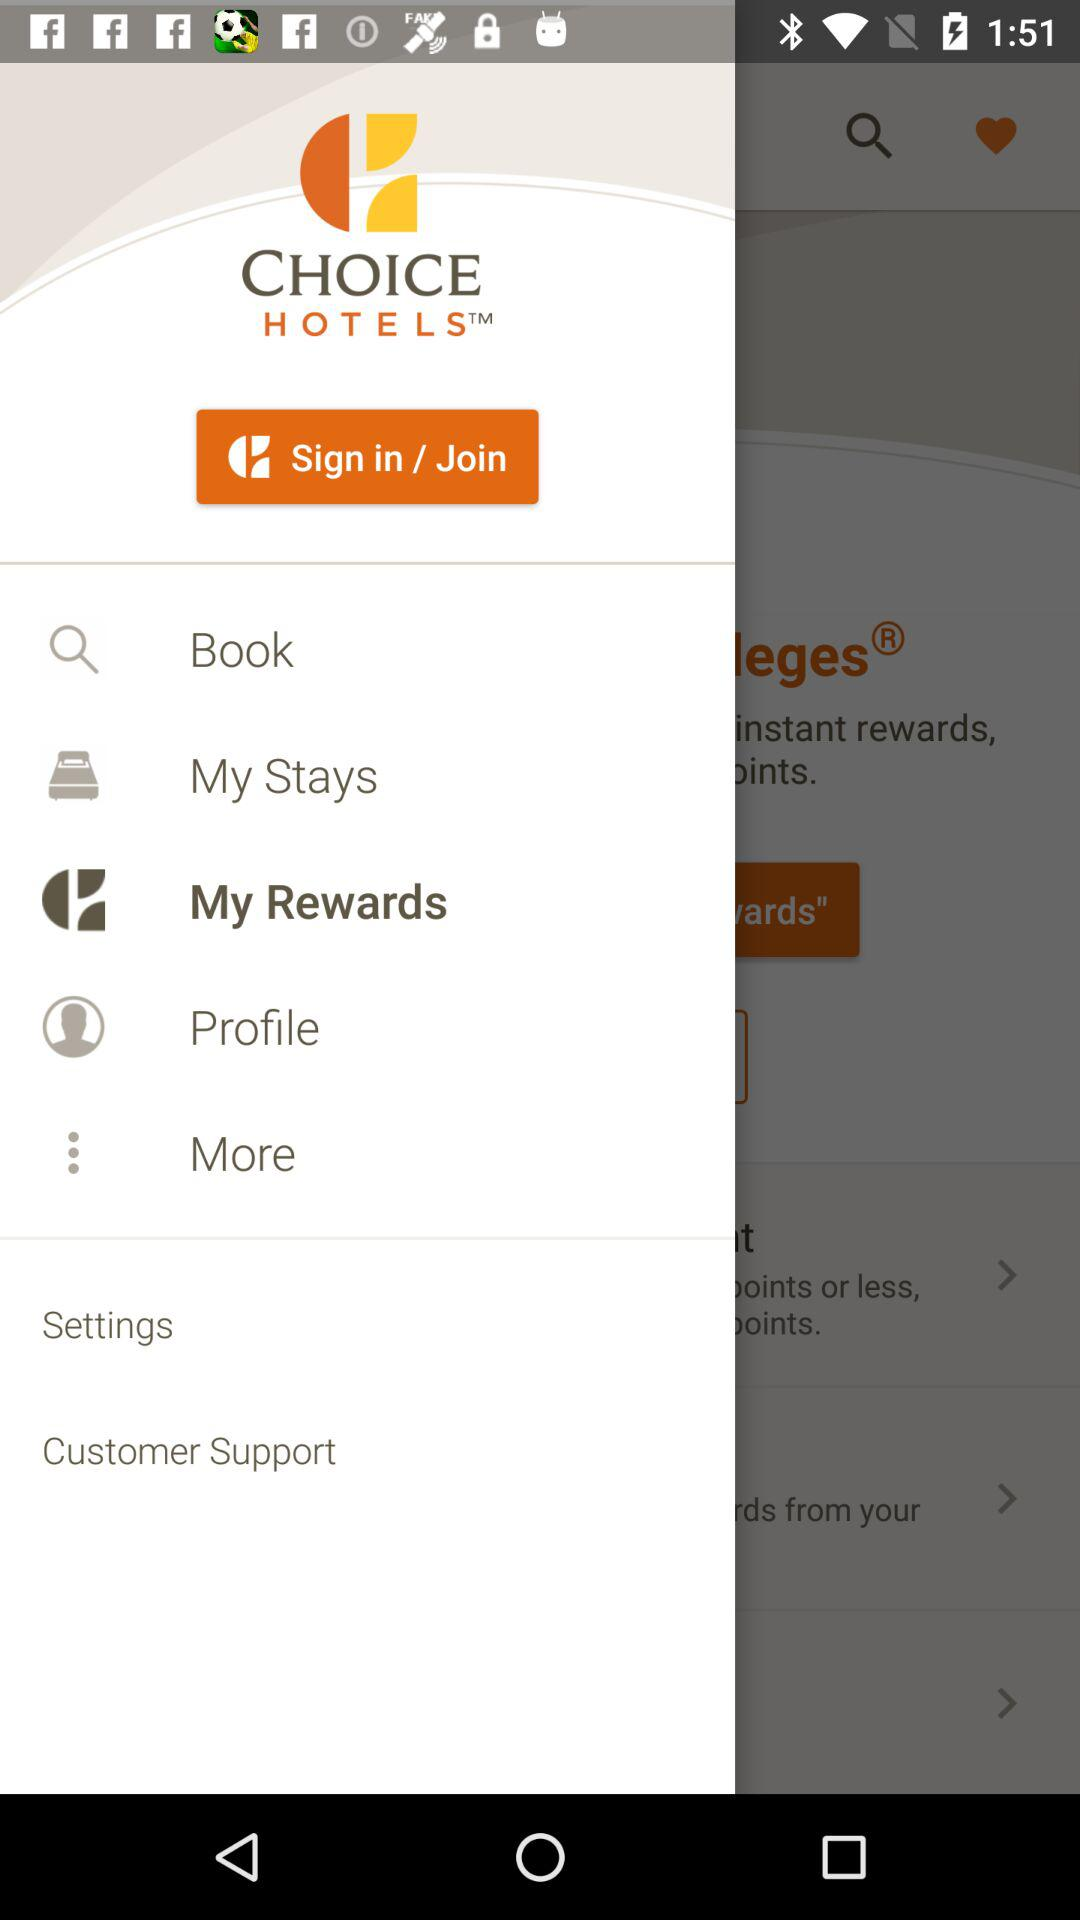Which item is selected? The selected item is "My Rewards". 